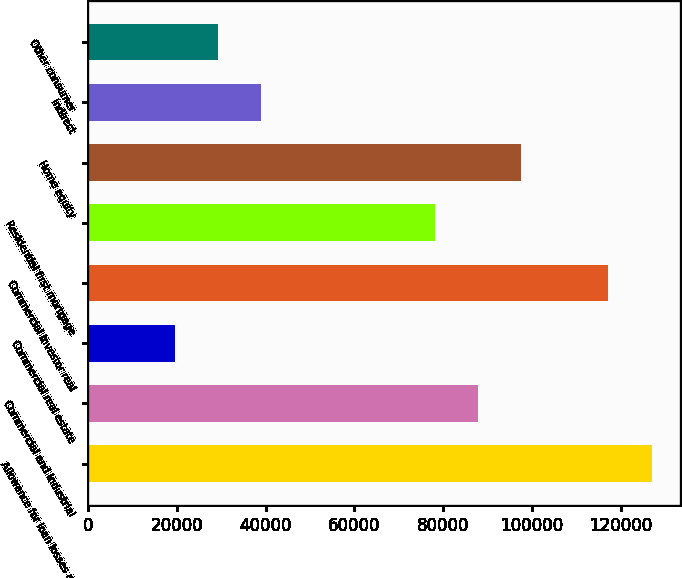<chart> <loc_0><loc_0><loc_500><loc_500><bar_chart><fcel>Allowance for loan losses at<fcel>Commercial and industrial<fcel>Commercial real estate<fcel>Commercial investor real<fcel>Residential first mortgage<fcel>Home equity<fcel>Indirect<fcel>Other consumer<nl><fcel>126881<fcel>87841.1<fcel>19521.5<fcel>117121<fcel>78081.1<fcel>97601<fcel>39041.3<fcel>29281.4<nl></chart> 